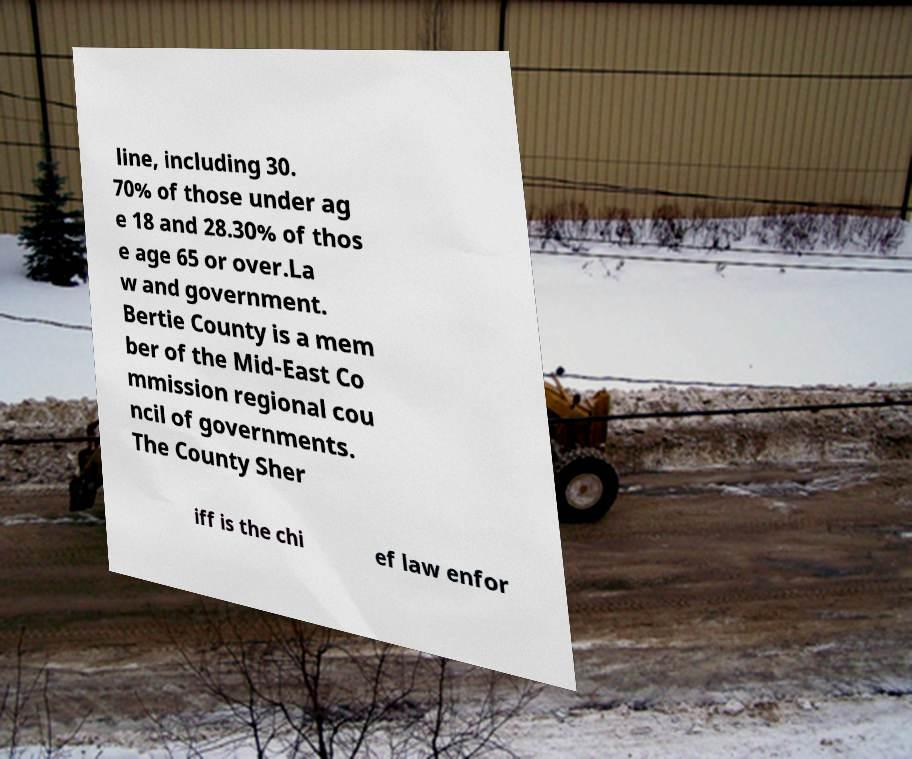Can you accurately transcribe the text from the provided image for me? line, including 30. 70% of those under ag e 18 and 28.30% of thos e age 65 or over.La w and government. Bertie County is a mem ber of the Mid-East Co mmission regional cou ncil of governments. The County Sher iff is the chi ef law enfor 